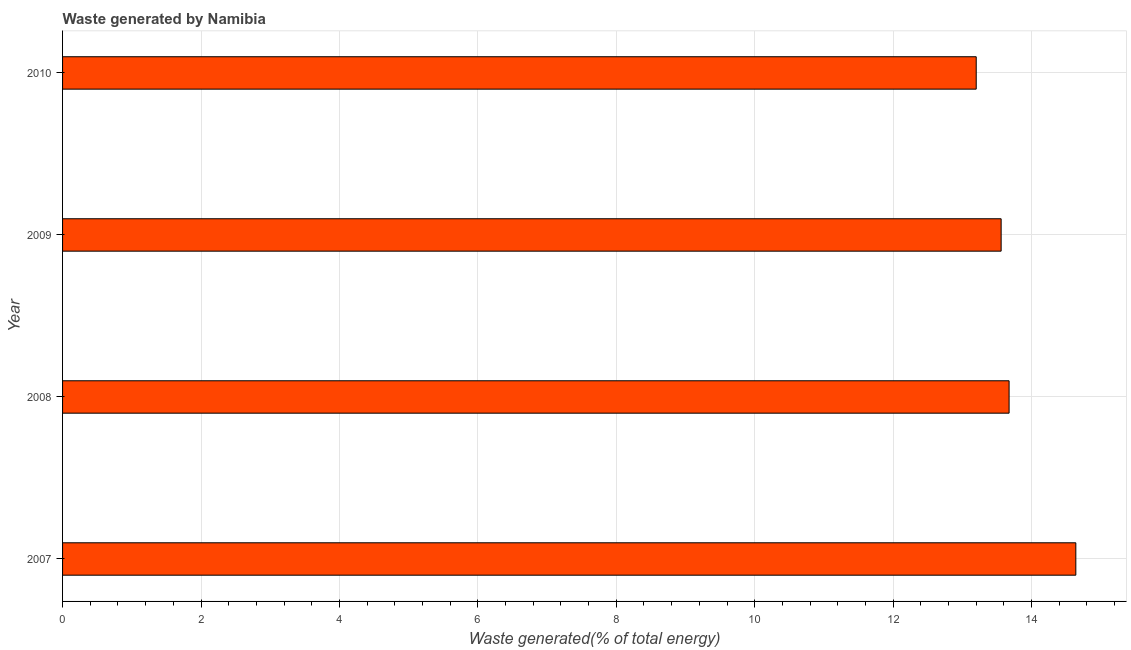Does the graph contain any zero values?
Offer a terse response. No. What is the title of the graph?
Provide a succinct answer. Waste generated by Namibia. What is the label or title of the X-axis?
Ensure brevity in your answer.  Waste generated(% of total energy). What is the label or title of the Y-axis?
Keep it short and to the point. Year. What is the amount of waste generated in 2007?
Your answer should be compact. 14.64. Across all years, what is the maximum amount of waste generated?
Your answer should be very brief. 14.64. Across all years, what is the minimum amount of waste generated?
Make the answer very short. 13.2. What is the sum of the amount of waste generated?
Give a very brief answer. 55.07. What is the average amount of waste generated per year?
Your answer should be very brief. 13.77. What is the median amount of waste generated?
Your answer should be very brief. 13.62. In how many years, is the amount of waste generated greater than 4.8 %?
Provide a succinct answer. 4. Is the amount of waste generated in 2008 less than that in 2010?
Provide a succinct answer. No. Is the difference between the amount of waste generated in 2007 and 2008 greater than the difference between any two years?
Your response must be concise. No. What is the difference between the highest and the second highest amount of waste generated?
Provide a short and direct response. 0.96. Is the sum of the amount of waste generated in 2007 and 2009 greater than the maximum amount of waste generated across all years?
Offer a terse response. Yes. What is the difference between the highest and the lowest amount of waste generated?
Offer a very short reply. 1.44. In how many years, is the amount of waste generated greater than the average amount of waste generated taken over all years?
Your response must be concise. 1. How many bars are there?
Provide a short and direct response. 4. Are the values on the major ticks of X-axis written in scientific E-notation?
Keep it short and to the point. No. What is the Waste generated(% of total energy) of 2007?
Offer a very short reply. 14.64. What is the Waste generated(% of total energy) of 2008?
Your response must be concise. 13.68. What is the Waste generated(% of total energy) in 2009?
Your answer should be compact. 13.56. What is the Waste generated(% of total energy) in 2010?
Your answer should be compact. 13.2. What is the difference between the Waste generated(% of total energy) in 2007 and 2008?
Your answer should be very brief. 0.96. What is the difference between the Waste generated(% of total energy) in 2007 and 2009?
Offer a terse response. 1.08. What is the difference between the Waste generated(% of total energy) in 2007 and 2010?
Ensure brevity in your answer.  1.44. What is the difference between the Waste generated(% of total energy) in 2008 and 2009?
Your answer should be compact. 0.12. What is the difference between the Waste generated(% of total energy) in 2008 and 2010?
Offer a terse response. 0.48. What is the difference between the Waste generated(% of total energy) in 2009 and 2010?
Your answer should be compact. 0.36. What is the ratio of the Waste generated(% of total energy) in 2007 to that in 2008?
Offer a very short reply. 1.07. What is the ratio of the Waste generated(% of total energy) in 2007 to that in 2009?
Keep it short and to the point. 1.08. What is the ratio of the Waste generated(% of total energy) in 2007 to that in 2010?
Provide a short and direct response. 1.11. What is the ratio of the Waste generated(% of total energy) in 2008 to that in 2009?
Provide a short and direct response. 1.01. What is the ratio of the Waste generated(% of total energy) in 2008 to that in 2010?
Your answer should be compact. 1.04. 